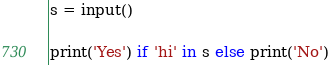Convert code to text. <code><loc_0><loc_0><loc_500><loc_500><_Python_>s = input()

print('Yes') if 'hi' in s else print('No')</code> 